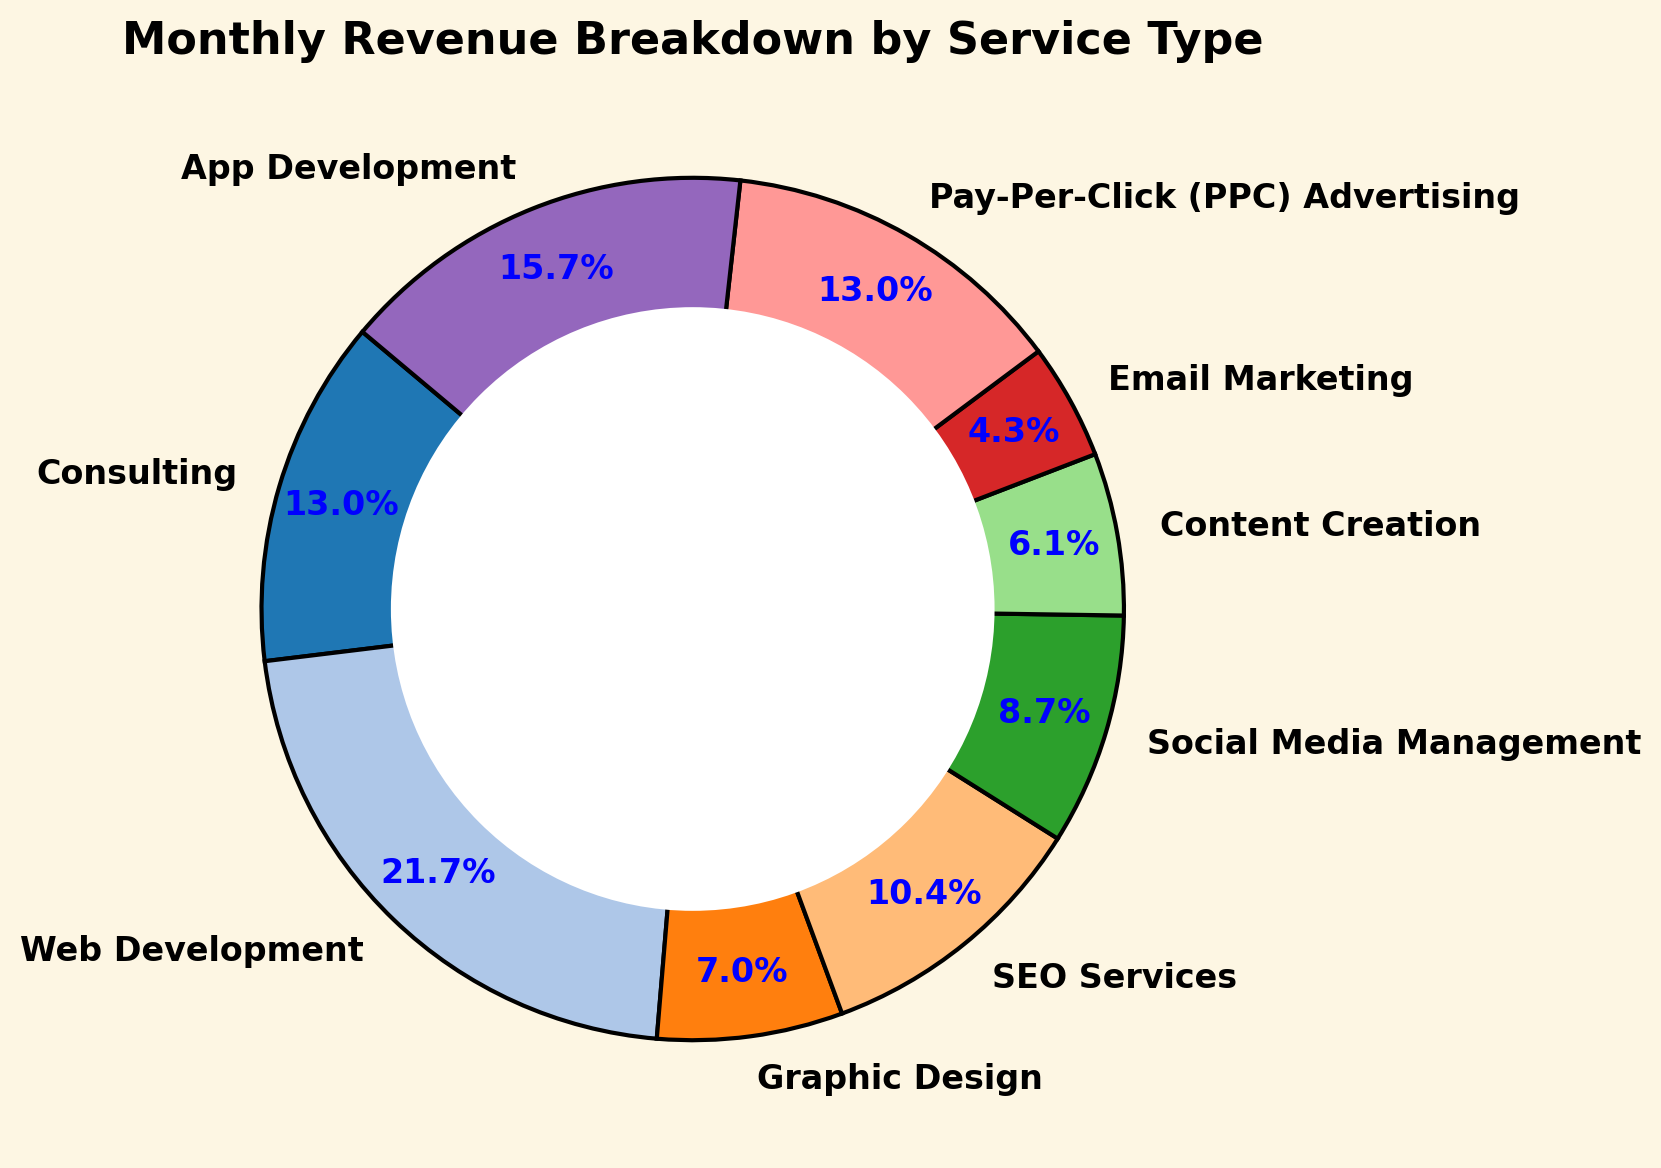Which service type contributes the highest percentage to the monthly revenue? By looking at the pie chart, the largest segment indicates the service type with the highest percentage.
Answer: Web Development Which two service types together contribute to over half of the total revenue? By identifying the two largest segments of the pie chart, we can sum their percentages to check if they exceed 50%.
Answer: Web Development and Consulting Which service type has a smaller revenue share than Social Media Management? Any segment smaller than the Social Media Management segment (which is labeled) will have a smaller share.
Answer: Content Creation, Email Marketing, and Graphic Design What is the total revenue contribution of App Development and SEO Services combined? By summing the percentage shares of App Development and SEO Services as shown in the chart.
Answer: 18,000 + 12,000 = 30,000 Is the revenue from Pay-Per-Click (PPC) Advertising greater than Social Media Management? Compare the segment sizes; the larger wedge will represent the greater revenue.
Answer: Yes Which segment has a blue font for the percentage text? Identifying the color of the percentage text directly from the pie chart.
Answer: All segments Which service type makes up exactly 10% of the total revenue? From the labels on the pie chart, locate the segment showing 10%.
Answer: Social Media Management What is the revenue difference between Consulting and Graphic Design? Subtract the revenue of Graphic Design from Consulting as indicated by their segments on the pie chart.
Answer: 15,000 - 8,000 = 7,000 Are there more service types or fewer service types contributing less than 10% of the revenue? Count the number of segments smaller than 10% and compare them to those 10% or larger.
Answer: Fewer 